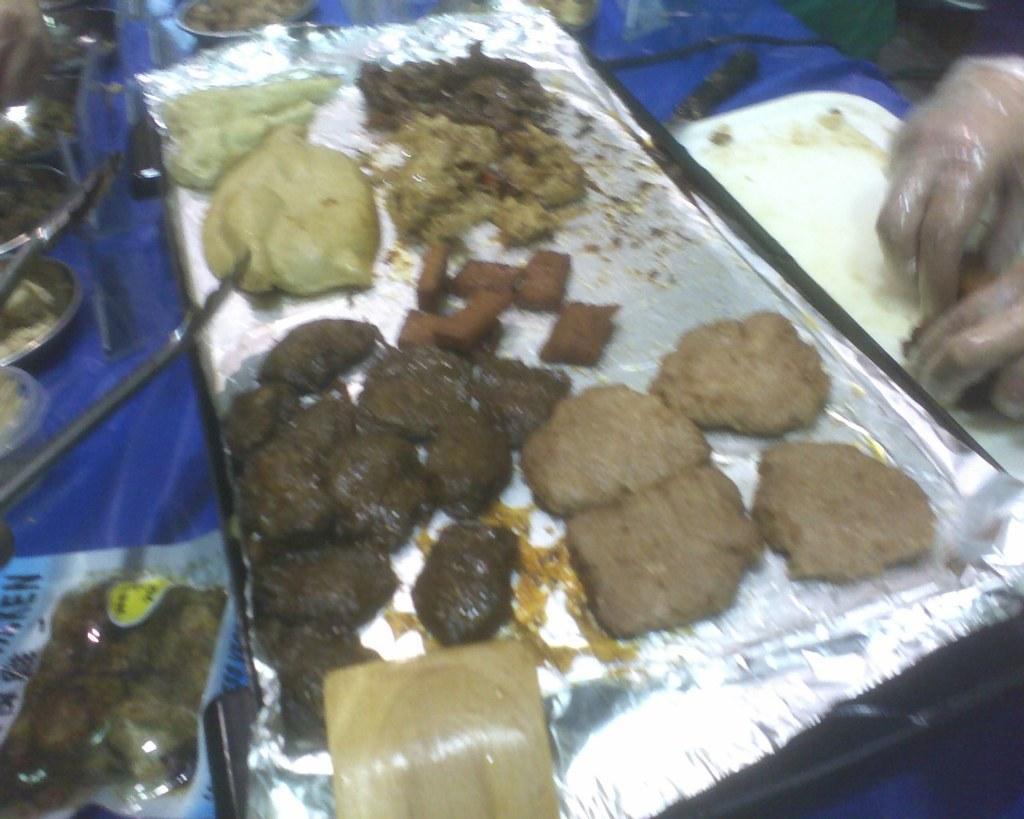How would you summarize this image in a sentence or two? In this picture I can see the food in a plate, on the right side there are human hands with covers. 